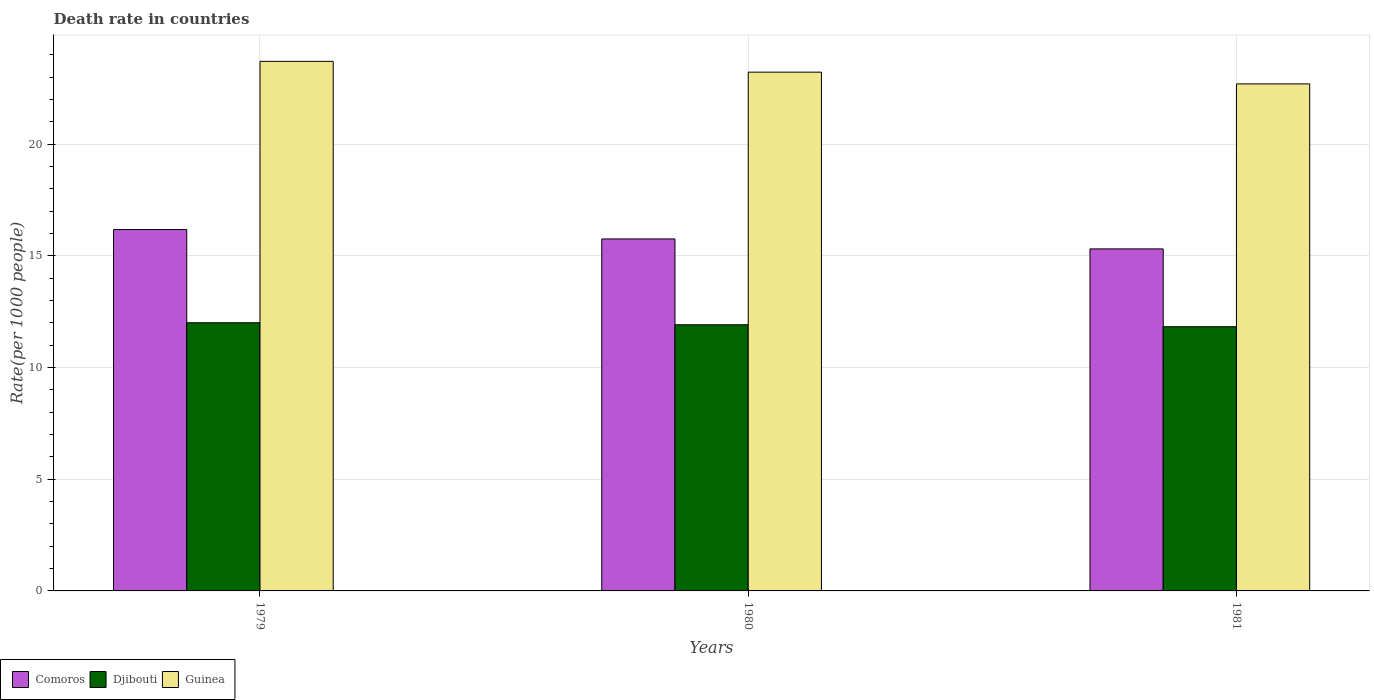How many different coloured bars are there?
Provide a succinct answer. 3. Are the number of bars per tick equal to the number of legend labels?
Your answer should be very brief. Yes. Are the number of bars on each tick of the X-axis equal?
Ensure brevity in your answer.  Yes. How many bars are there on the 3rd tick from the left?
Offer a very short reply. 3. What is the death rate in Comoros in 1979?
Ensure brevity in your answer.  16.18. Across all years, what is the maximum death rate in Djibouti?
Keep it short and to the point. 12.01. Across all years, what is the minimum death rate in Comoros?
Offer a very short reply. 15.31. In which year was the death rate in Comoros maximum?
Ensure brevity in your answer.  1979. What is the total death rate in Guinea in the graph?
Make the answer very short. 69.64. What is the difference between the death rate in Djibouti in 1980 and that in 1981?
Provide a short and direct response. 0.09. What is the difference between the death rate in Djibouti in 1979 and the death rate in Comoros in 1980?
Your answer should be very brief. -3.75. What is the average death rate in Djibouti per year?
Ensure brevity in your answer.  11.92. In the year 1979, what is the difference between the death rate in Guinea and death rate in Djibouti?
Provide a short and direct response. 11.7. In how many years, is the death rate in Guinea greater than 15?
Offer a very short reply. 3. What is the ratio of the death rate in Djibouti in 1979 to that in 1981?
Ensure brevity in your answer.  1.02. Is the death rate in Comoros in 1979 less than that in 1980?
Keep it short and to the point. No. What is the difference between the highest and the second highest death rate in Guinea?
Keep it short and to the point. 0.48. What is the difference between the highest and the lowest death rate in Guinea?
Offer a very short reply. 1.01. In how many years, is the death rate in Guinea greater than the average death rate in Guinea taken over all years?
Offer a very short reply. 2. Is the sum of the death rate in Djibouti in 1980 and 1981 greater than the maximum death rate in Comoros across all years?
Your answer should be compact. Yes. What does the 1st bar from the left in 1979 represents?
Ensure brevity in your answer.  Comoros. What does the 1st bar from the right in 1979 represents?
Your answer should be very brief. Guinea. Is it the case that in every year, the sum of the death rate in Comoros and death rate in Djibouti is greater than the death rate in Guinea?
Your answer should be very brief. Yes. How many bars are there?
Offer a terse response. 9. Are all the bars in the graph horizontal?
Give a very brief answer. No. How many years are there in the graph?
Give a very brief answer. 3. Are the values on the major ticks of Y-axis written in scientific E-notation?
Offer a very short reply. No. Does the graph contain any zero values?
Your response must be concise. No. Does the graph contain grids?
Keep it short and to the point. Yes. How are the legend labels stacked?
Make the answer very short. Horizontal. What is the title of the graph?
Provide a succinct answer. Death rate in countries. Does "Brunei Darussalam" appear as one of the legend labels in the graph?
Provide a succinct answer. No. What is the label or title of the X-axis?
Make the answer very short. Years. What is the label or title of the Y-axis?
Keep it short and to the point. Rate(per 1000 people). What is the Rate(per 1000 people) of Comoros in 1979?
Offer a very short reply. 16.18. What is the Rate(per 1000 people) in Djibouti in 1979?
Offer a very short reply. 12.01. What is the Rate(per 1000 people) of Guinea in 1979?
Provide a succinct answer. 23.71. What is the Rate(per 1000 people) in Comoros in 1980?
Offer a terse response. 15.76. What is the Rate(per 1000 people) of Djibouti in 1980?
Provide a succinct answer. 11.92. What is the Rate(per 1000 people) of Guinea in 1980?
Offer a terse response. 23.23. What is the Rate(per 1000 people) of Comoros in 1981?
Offer a terse response. 15.31. What is the Rate(per 1000 people) in Djibouti in 1981?
Your answer should be very brief. 11.83. What is the Rate(per 1000 people) of Guinea in 1981?
Offer a very short reply. 22.7. Across all years, what is the maximum Rate(per 1000 people) of Comoros?
Offer a very short reply. 16.18. Across all years, what is the maximum Rate(per 1000 people) in Djibouti?
Provide a short and direct response. 12.01. Across all years, what is the maximum Rate(per 1000 people) of Guinea?
Offer a very short reply. 23.71. Across all years, what is the minimum Rate(per 1000 people) in Comoros?
Your response must be concise. 15.31. Across all years, what is the minimum Rate(per 1000 people) of Djibouti?
Offer a terse response. 11.83. Across all years, what is the minimum Rate(per 1000 people) of Guinea?
Provide a short and direct response. 22.7. What is the total Rate(per 1000 people) in Comoros in the graph?
Your answer should be very brief. 47.25. What is the total Rate(per 1000 people) in Djibouti in the graph?
Your answer should be compact. 35.75. What is the total Rate(per 1000 people) of Guinea in the graph?
Offer a very short reply. 69.64. What is the difference between the Rate(per 1000 people) of Comoros in 1979 and that in 1980?
Your answer should be compact. 0.42. What is the difference between the Rate(per 1000 people) of Djibouti in 1979 and that in 1980?
Offer a terse response. 0.09. What is the difference between the Rate(per 1000 people) in Guinea in 1979 and that in 1980?
Provide a short and direct response. 0.48. What is the difference between the Rate(per 1000 people) of Comoros in 1979 and that in 1981?
Give a very brief answer. 0.87. What is the difference between the Rate(per 1000 people) of Djibouti in 1979 and that in 1981?
Ensure brevity in your answer.  0.18. What is the difference between the Rate(per 1000 people) in Comoros in 1980 and that in 1981?
Your answer should be very brief. 0.45. What is the difference between the Rate(per 1000 people) in Djibouti in 1980 and that in 1981?
Give a very brief answer. 0.09. What is the difference between the Rate(per 1000 people) in Guinea in 1980 and that in 1981?
Offer a terse response. 0.53. What is the difference between the Rate(per 1000 people) of Comoros in 1979 and the Rate(per 1000 people) of Djibouti in 1980?
Keep it short and to the point. 4.26. What is the difference between the Rate(per 1000 people) in Comoros in 1979 and the Rate(per 1000 people) in Guinea in 1980?
Ensure brevity in your answer.  -7.05. What is the difference between the Rate(per 1000 people) in Djibouti in 1979 and the Rate(per 1000 people) in Guinea in 1980?
Offer a very short reply. -11.22. What is the difference between the Rate(per 1000 people) of Comoros in 1979 and the Rate(per 1000 people) of Djibouti in 1981?
Keep it short and to the point. 4.35. What is the difference between the Rate(per 1000 people) in Comoros in 1979 and the Rate(per 1000 people) in Guinea in 1981?
Provide a succinct answer. -6.52. What is the difference between the Rate(per 1000 people) of Djibouti in 1979 and the Rate(per 1000 people) of Guinea in 1981?
Offer a very short reply. -10.69. What is the difference between the Rate(per 1000 people) in Comoros in 1980 and the Rate(per 1000 people) in Djibouti in 1981?
Make the answer very short. 3.93. What is the difference between the Rate(per 1000 people) of Comoros in 1980 and the Rate(per 1000 people) of Guinea in 1981?
Offer a terse response. -6.94. What is the difference between the Rate(per 1000 people) in Djibouti in 1980 and the Rate(per 1000 people) in Guinea in 1981?
Your answer should be compact. -10.78. What is the average Rate(per 1000 people) of Comoros per year?
Offer a very short reply. 15.75. What is the average Rate(per 1000 people) in Djibouti per year?
Give a very brief answer. 11.92. What is the average Rate(per 1000 people) of Guinea per year?
Your answer should be very brief. 23.21. In the year 1979, what is the difference between the Rate(per 1000 people) in Comoros and Rate(per 1000 people) in Djibouti?
Ensure brevity in your answer.  4.17. In the year 1979, what is the difference between the Rate(per 1000 people) in Comoros and Rate(per 1000 people) in Guinea?
Offer a very short reply. -7.53. In the year 1979, what is the difference between the Rate(per 1000 people) in Djibouti and Rate(per 1000 people) in Guinea?
Make the answer very short. -11.7. In the year 1980, what is the difference between the Rate(per 1000 people) in Comoros and Rate(per 1000 people) in Djibouti?
Your answer should be very brief. 3.84. In the year 1980, what is the difference between the Rate(per 1000 people) in Comoros and Rate(per 1000 people) in Guinea?
Your answer should be compact. -7.47. In the year 1980, what is the difference between the Rate(per 1000 people) in Djibouti and Rate(per 1000 people) in Guinea?
Provide a short and direct response. -11.31. In the year 1981, what is the difference between the Rate(per 1000 people) in Comoros and Rate(per 1000 people) in Djibouti?
Make the answer very short. 3.48. In the year 1981, what is the difference between the Rate(per 1000 people) of Comoros and Rate(per 1000 people) of Guinea?
Keep it short and to the point. -7.39. In the year 1981, what is the difference between the Rate(per 1000 people) of Djibouti and Rate(per 1000 people) of Guinea?
Offer a very short reply. -10.87. What is the ratio of the Rate(per 1000 people) of Comoros in 1979 to that in 1980?
Provide a succinct answer. 1.03. What is the ratio of the Rate(per 1000 people) in Djibouti in 1979 to that in 1980?
Your answer should be very brief. 1.01. What is the ratio of the Rate(per 1000 people) of Guinea in 1979 to that in 1980?
Provide a succinct answer. 1.02. What is the ratio of the Rate(per 1000 people) in Comoros in 1979 to that in 1981?
Offer a terse response. 1.06. What is the ratio of the Rate(per 1000 people) of Djibouti in 1979 to that in 1981?
Provide a succinct answer. 1.01. What is the ratio of the Rate(per 1000 people) of Guinea in 1979 to that in 1981?
Your answer should be very brief. 1.04. What is the ratio of the Rate(per 1000 people) in Comoros in 1980 to that in 1981?
Provide a succinct answer. 1.03. What is the ratio of the Rate(per 1000 people) of Djibouti in 1980 to that in 1981?
Your answer should be very brief. 1.01. What is the ratio of the Rate(per 1000 people) in Guinea in 1980 to that in 1981?
Your answer should be compact. 1.02. What is the difference between the highest and the second highest Rate(per 1000 people) in Comoros?
Provide a succinct answer. 0.42. What is the difference between the highest and the second highest Rate(per 1000 people) of Djibouti?
Offer a very short reply. 0.09. What is the difference between the highest and the second highest Rate(per 1000 people) of Guinea?
Your response must be concise. 0.48. What is the difference between the highest and the lowest Rate(per 1000 people) of Comoros?
Your answer should be compact. 0.87. What is the difference between the highest and the lowest Rate(per 1000 people) of Djibouti?
Make the answer very short. 0.18. What is the difference between the highest and the lowest Rate(per 1000 people) of Guinea?
Your answer should be very brief. 1.01. 